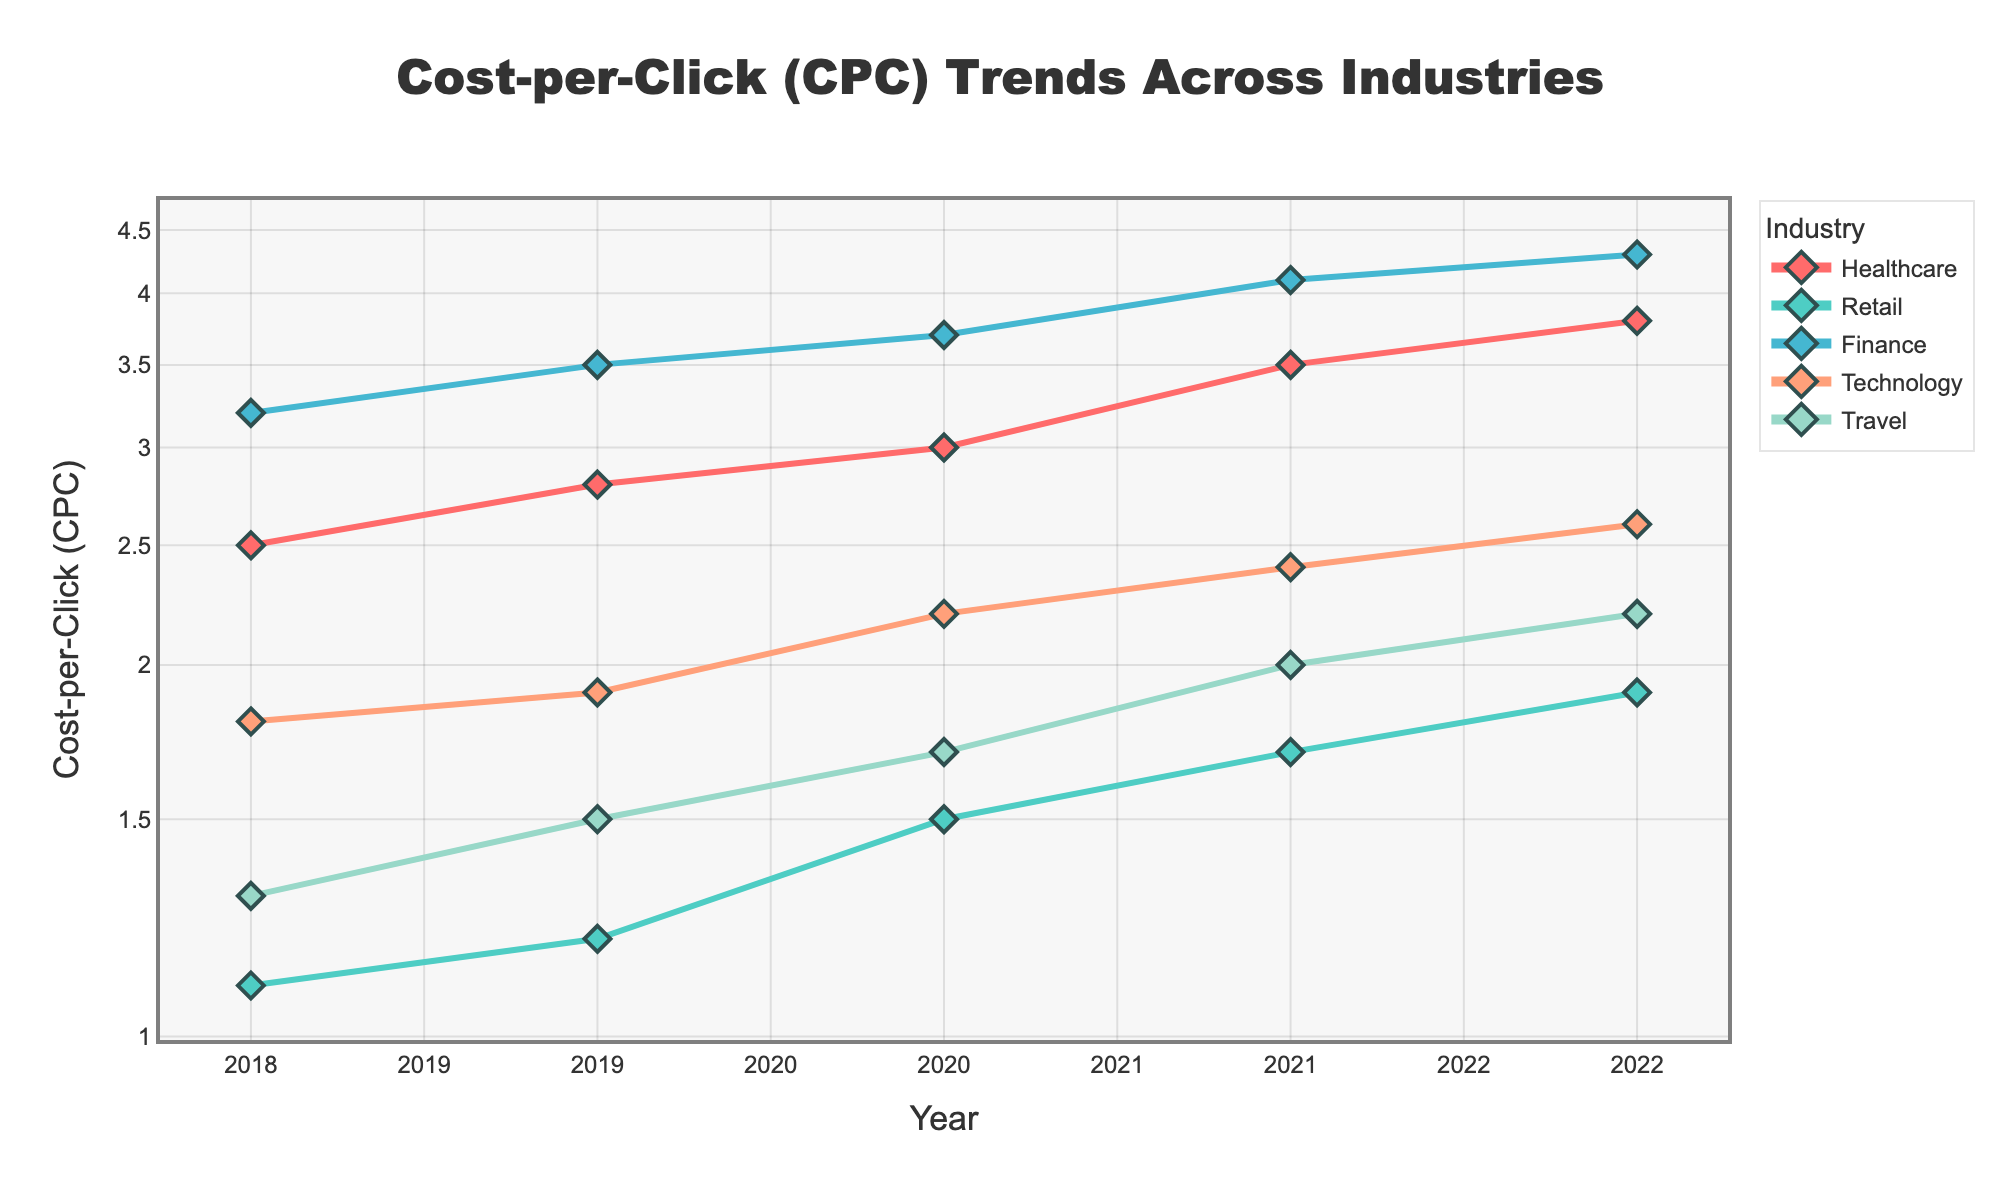What is the CPC trend in the Healthcare industry from 2018 to 2022? The figure shows the CPC values for Healthcare from 2018 to 2022. Observing the y-values for each year, we see an upward trend: 2.5 in 2018, 2.8 in 2019, 3.0 in 2020, 3.5 in 2021, and 3.8 in 2022.
Answer: Upward trend Which industry had the highest CPC in 2019? By looking at the 2019 data points, Finance had the highest CPC of 3.5, surpassing the CPC values of other industries.
Answer: Finance What is the difference in CPC between Retail and Technology in 2020? The CPC for Retail in 2020 was 1.5, and for Technology, it was 2.2. Thus, the difference is 2.2 - 1.5 = 0.7.
Answer: 0.7 Did any industry experience a decreasing trend in CPC over the period from 2018 to 2022? Examining all industries' trends, none show a decrease in the CPC values; all show an upward trend.
Answer: No What was the average CPC for the Travel industry between 2018 and 2022? The CPC values for Travel from 2018 to 2022 are 1.3, 1.5, 1.7, 2.0, and 2.2. The average is (1.3 + 1.5 + 1.7 + 2.0 + 2.2) / 5 = 8.7 / 5 = 1.74.
Answer: 1.74 How did the CPC for Finance change from 2021 to 2022? The CPC for Finance in 2021 was 4.1 and in 2022 it was 4.3. The change is 4.3 - 4.1 = 0.2.
Answer: Increased by 0.2 Which industry has the most significant increase in CPC from 2018 to 2022? Finance went from 3.2 in 2018 to 4.3 in 2022, an increase of 4.3 - 3.2 = 1.1, which is the largest increase compared to other industries.
Answer: Finance What was the CPC for the Retail industry in 2019? Looking at the Retail CPC value in 2019, it is marked at 1.2.
Answer: 1.2 Comparing Healthcare and Travel in 2021, which had the higher CPC and by how much? In 2021, Healthcare had a CPC of 3.5 and Travel had 2.0. The difference is 3.5 - 2.0 = 1.5, with Healthcare having the higher CPC.
Answer: Healthcare by 1.5 Which industry's CPC was closest to 2.0 in 2020? In 2020, the Technology industry's CPC was 2.2, which is the closest to 2.0 compared to other industries.
Answer: Technology 